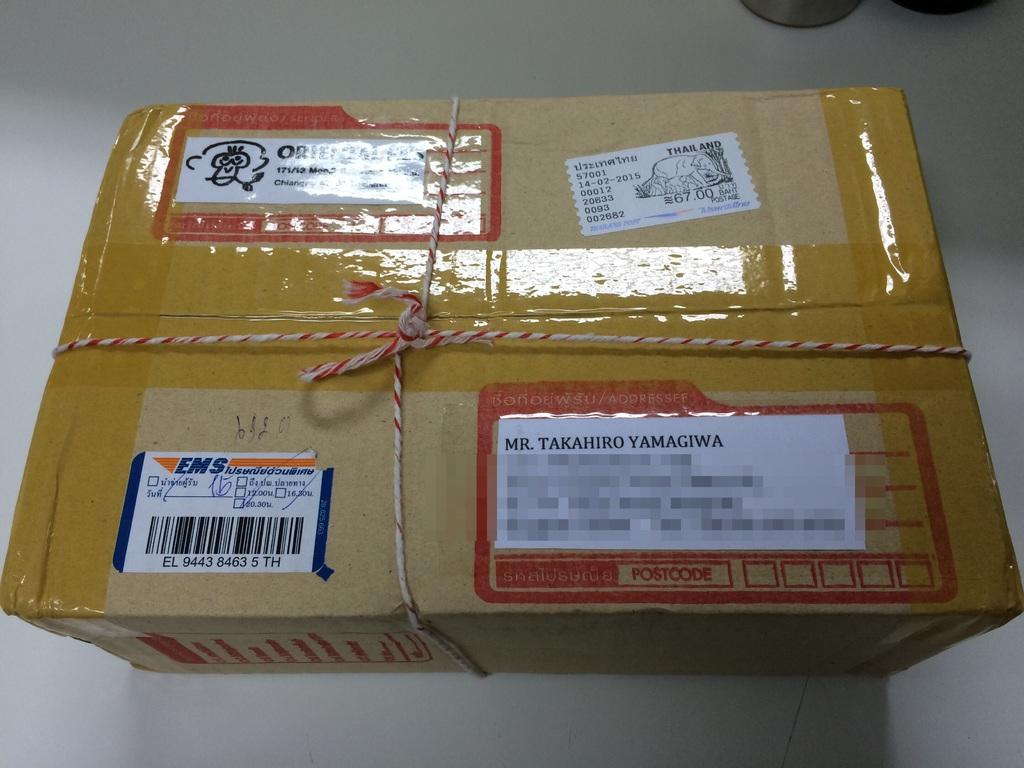<image>
Give a short and clear explanation of the subsequent image. A package secured with tape and twine is addressed to Takahiro Yamagiwa. 